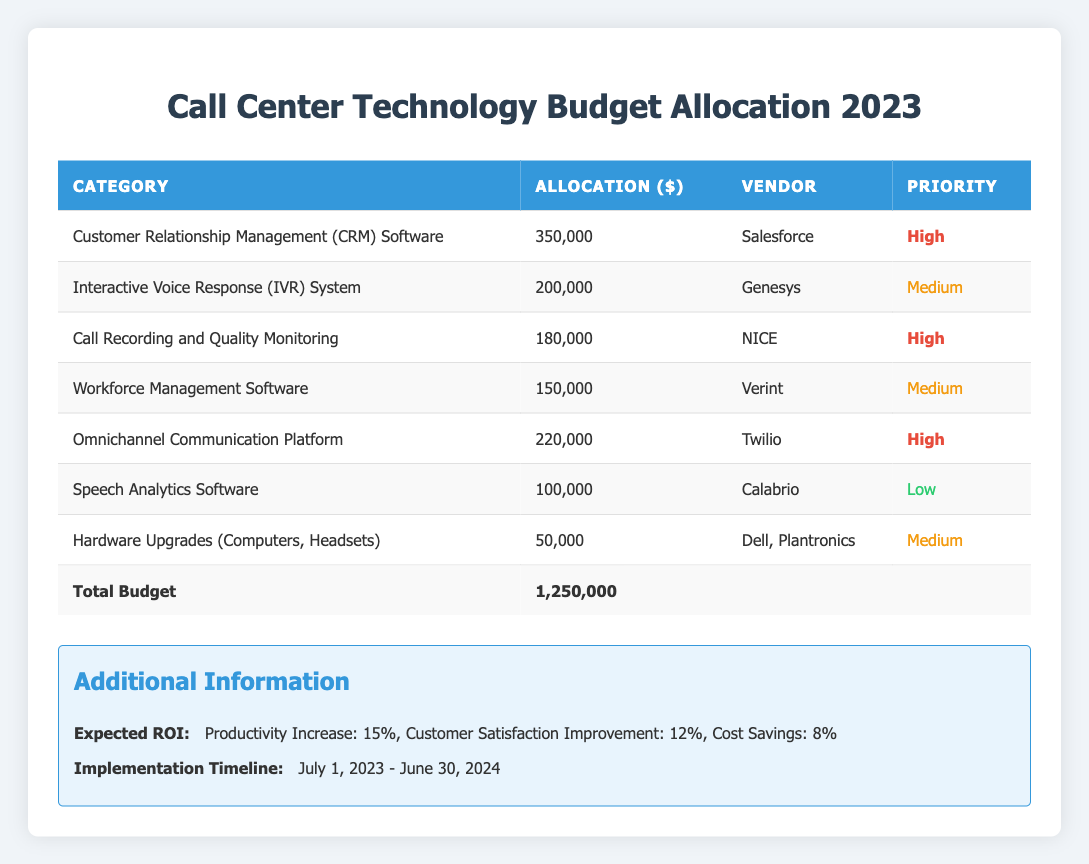What is the total budget allocated for call center technology upgrades in 2023? The table states the total budget for the year 2023 is 1,250,000 dollars, which is located in the last row under the "Total Budget" category.
Answer: 1,250,000 Which technology category has the highest allocation? By examining the "Allocation ($)" column, the highest value is 350,000 assigned to the "Customer Relationship Management (CRM) Software," making it the highest budgeted category.
Answer: Customer Relationship Management (CRM) Software How much budget is allocated to low-priority technology? There is only one low-priority category listed in the table, "Speech Analytics Software," which has an allocation of 100,000 dollars. Thus, the total budget for low-priority technology is equal to this single value.
Answer: 100,000 What is the combined allocation for medium-priority categories? The medium-priority categories are "Interactive Voice Response (IVR) System" (200,000), "Workforce Management Software" (150,000), and "Hardware Upgrades" (50,000). Adding these values: 200,000 + 150,000 + 50,000 equals 400,000 dollars for the medium-priority allocations.
Answer: 400,000 Is there a category allocated more than 200,000 dollars that is considered high priority? The table shows two categories with allocations over 200,000: "Customer Relationship Management (CRM) Software" (350,000) and "Omnichannel Communication Platform" (220,000). Both are classified as high priority. Therefore, the answer is yes.
Answer: Yes What percentage of the total budget is allocated to the "Omnichannel Communication Platform"? The platform is allocated 220,000 dollars. To find the percentage, divide the allocation by the total budget and multiply by 100: (220,000 / 1,250,000) * 100 equals 17.6 percent of the total budget.
Answer: 17.6% Which vendor provides the technology with the lowest priority and what is its allocation? The "Speech Analytics Software" is provided by Calabrio and has an allocation of 100,000 dollars. It is classified as low priority according to the table.
Answer: Calabrio, 100,000 What is the total expected ROI in terms of productivity increase, customer satisfaction improvement, and cost savings combined? The expected ROI combines three percentages: productivity increase (15%), customer satisfaction improvement (12%), and cost savings (8%). The combined percentage is calculated as 15 + 12 + 8, giving a total of 35 percent.
Answer: 35% 